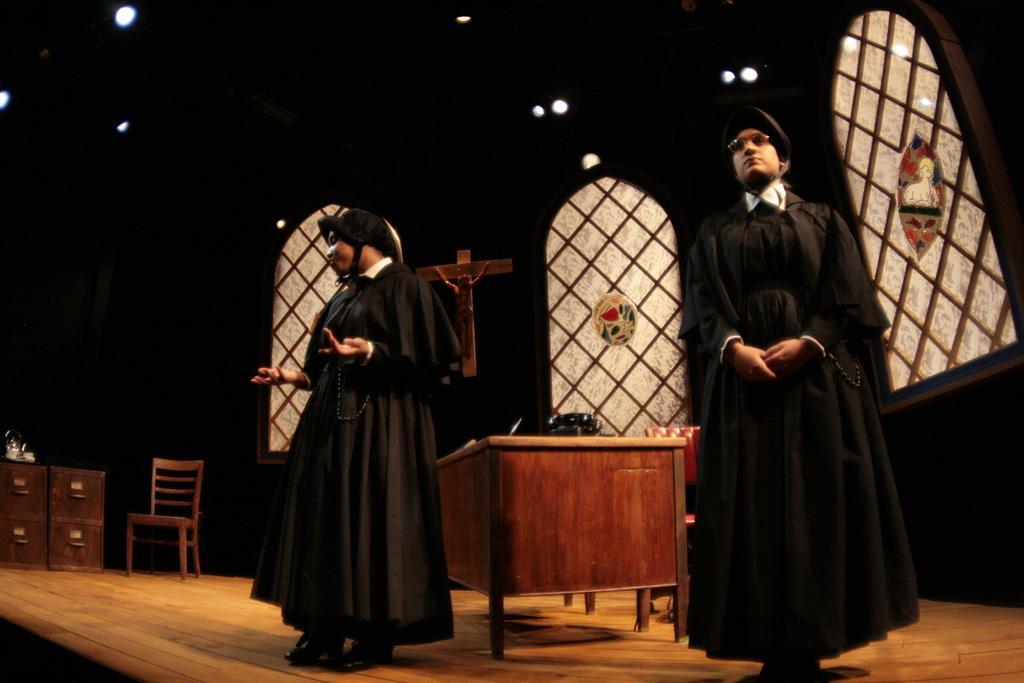In one or two sentences, can you explain what this image depicts? In the picture I can see these two persons wearing black color dresses are standing on the wooden floor, here I can see table, chairs, cupboards and the background of the image is dark, where I can see the cross symbol and stained glass. 